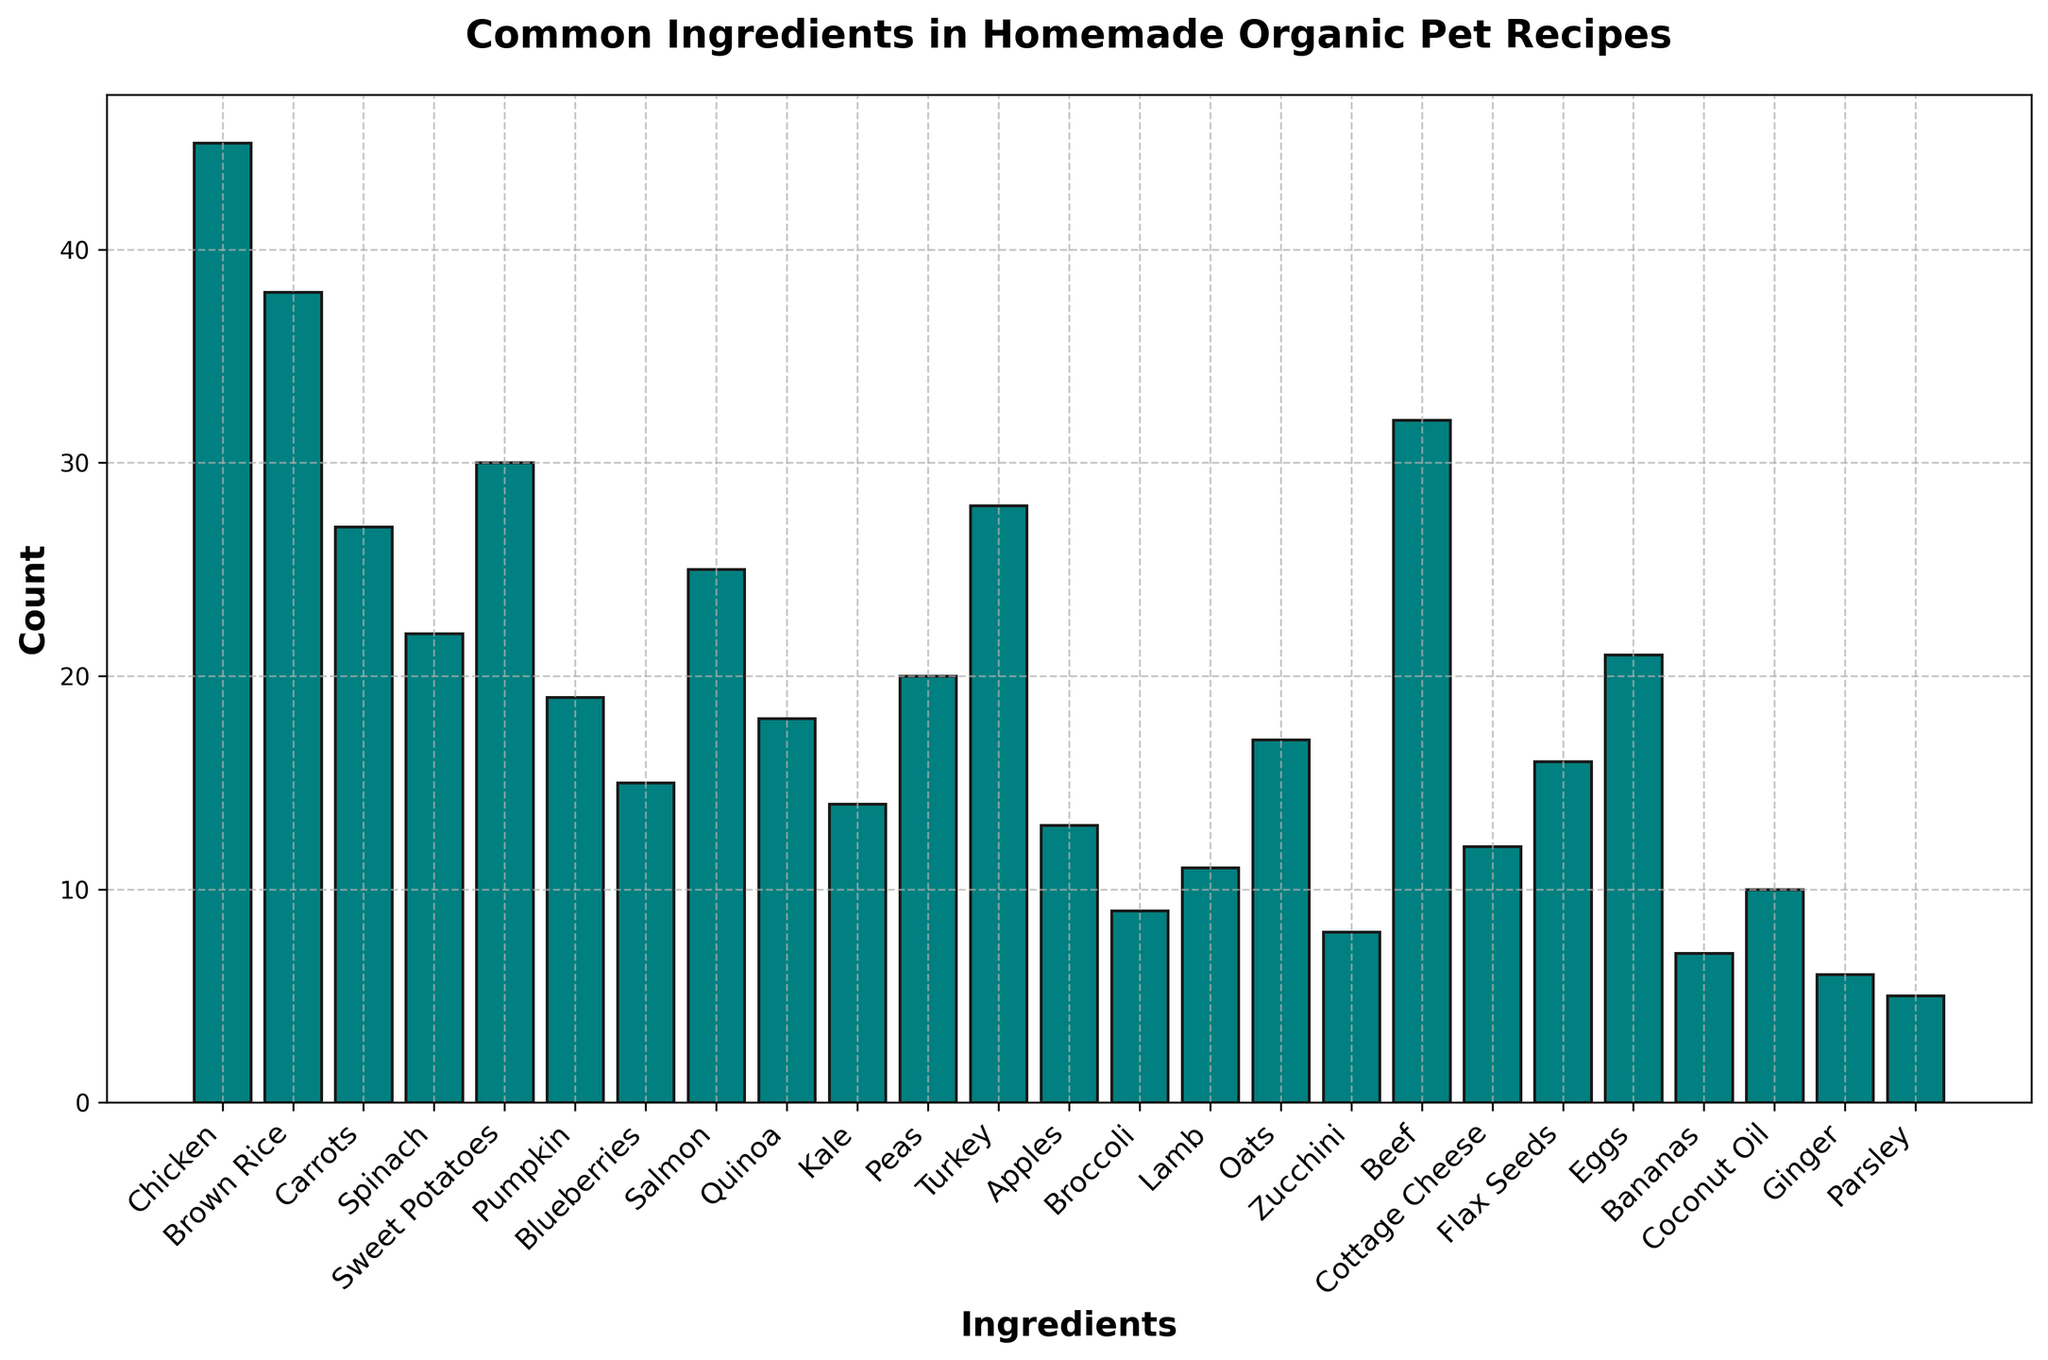What is the most common ingredient in homemade organic pet recipes? The most common ingredient is identified by the highest bar in the histogram. By looking at the figure, we can see that the bar for Chicken is the tallest.
Answer: Chicken Which ingredient appears exactly 30 times in the recipes? To find this ingredient, look for the bar corresponding to a count of 30. The ingredient with a bar height of 30 in the figure is Sweet Potatoes.
Answer: Sweet Potatoes How many more times is Chicken used compared to Broccoli? Determine the counts for Chicken and Broccoli first. Chicken has a count of 45 and Broccoli has a count of 9. Subtracting the count of Broccoli from Chicken gives 45 - 9 = 36.
Answer: 36 Which ingredient has a count closest to the average count of all ingredients? To find the average count: sum all counts (45 + 38 + 27 + 22 + 30 + 19 + 15 + 25 + 18 + 14 + 20 + 28 + 13 + 9 + 11 + 17 + 8 + 32 + 12 + 16 + 21 + 7 + 10 + 6 + 5 = 431) and divide by the number of ingredients (25), which gives 431/25 = 17.24. The ingredient with a count closest to 17.24 is Oats with a count of 17.
Answer: Oats Are there more fruits or vegetables in the recipes based on the ingredient counts? Fruits: Blueberries (15), Apples (13), Bananas (7); total = 35. Vegetables: Carrots (27), Spinach (22), Sweet Potatoes (30), Pumpkin (19), Kale (14), Peas (20), Broccoli (9), Zucchini (8); total = 149. Since 149 > 35, there are more vegetables.
Answer: Vegetables Which ingredient is used less frequently, Turkey or Salmon? Check the counts for Turkey (28) and Salmon (25). Since 25 < 28, Salmon is used less frequently than Turkey.
Answer: Salmon What's the total count for meat-based ingredients (Chicken, Salmon, Turkey, Lamb, Beef)? Sum the counts for meat-based ingredients: Chicken (45) + Salmon (25) + Turkey (28) + Lamb (11) + Beef (32). Adding these gives 45 + 25 + 28 + 11 + 32 = 141.
Answer: 141 Which ingredient count is exactly halfway between the highest and lowest counts? The highest count is 45 (Chicken) and the lowest is 5 (Parsley). The midpoint between these values is (45 + 5)/2 = 25. The ingredient with a count of 25 is Salmon.
Answer: Salmon 